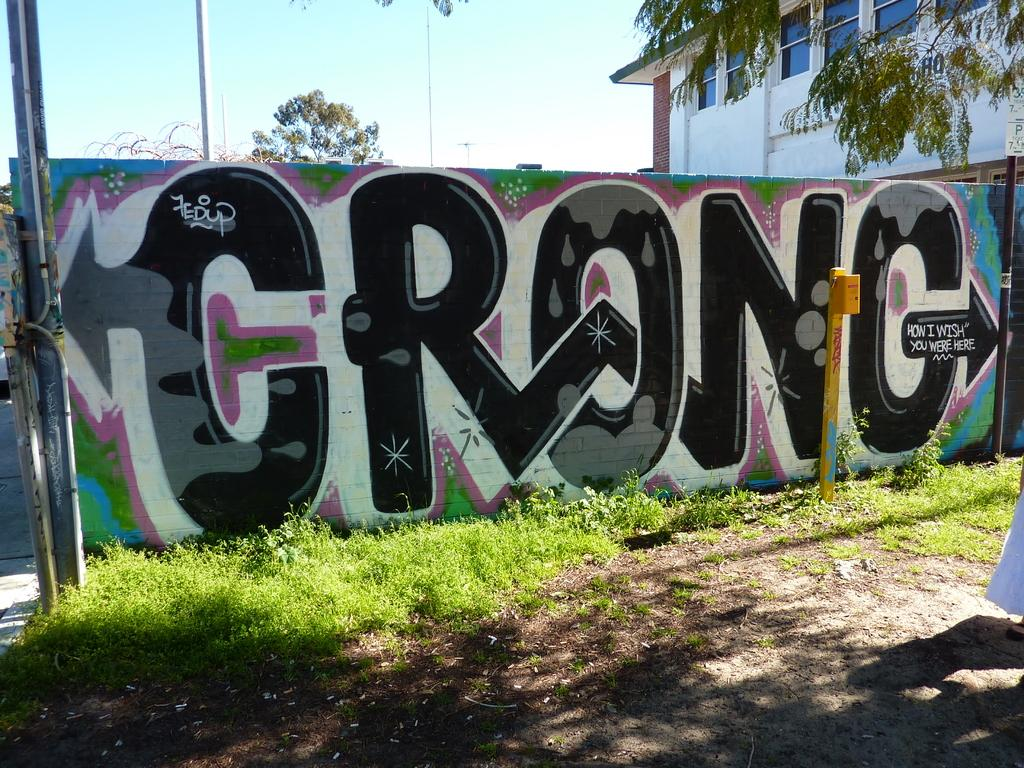What type of vegetation can be seen in the image? There is grass in the image. What can be observed in relation to the light source in the image? Shadows are visible in the image. What structures are present in the image? There are poles and a building in the image. What type of natural elements can be seen in the image? There are trees in the image. What is visible in the background of the image? The sky is visible in the image. What type of artwork is present in the image? There is a painting on a wall in the image. What type of knee injury is depicted in the painting on the wall? There is no painting of a knee injury present in the image; the painting on the wall is not described in the provided facts. 